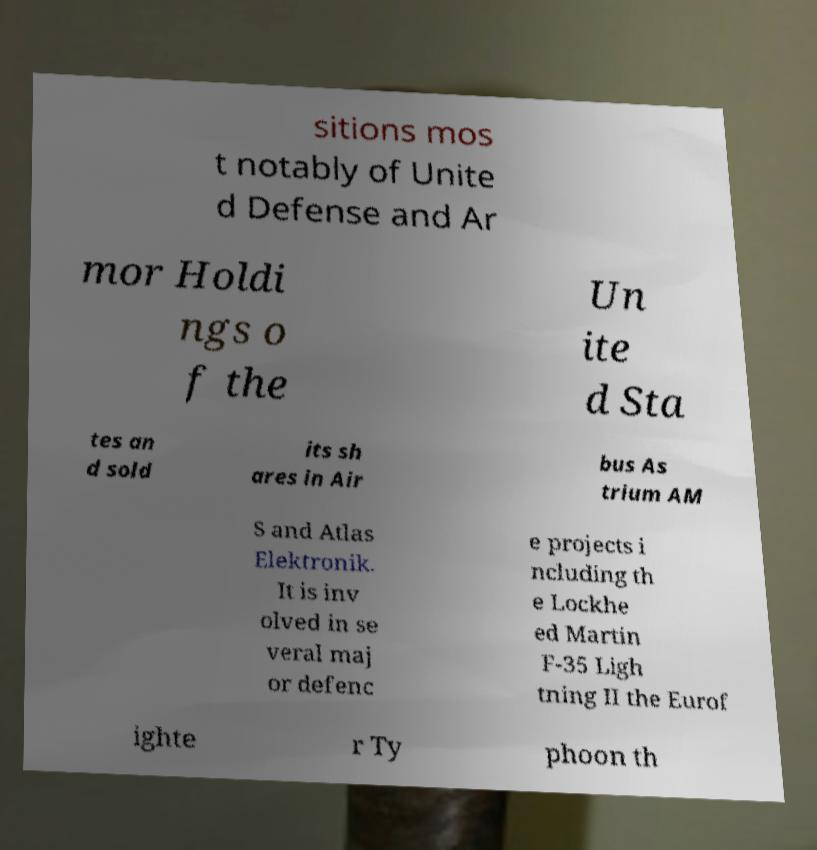Please identify and transcribe the text found in this image. sitions mos t notably of Unite d Defense and Ar mor Holdi ngs o f the Un ite d Sta tes an d sold its sh ares in Air bus As trium AM S and Atlas Elektronik. It is inv olved in se veral maj or defenc e projects i ncluding th e Lockhe ed Martin F-35 Ligh tning II the Eurof ighte r Ty phoon th 